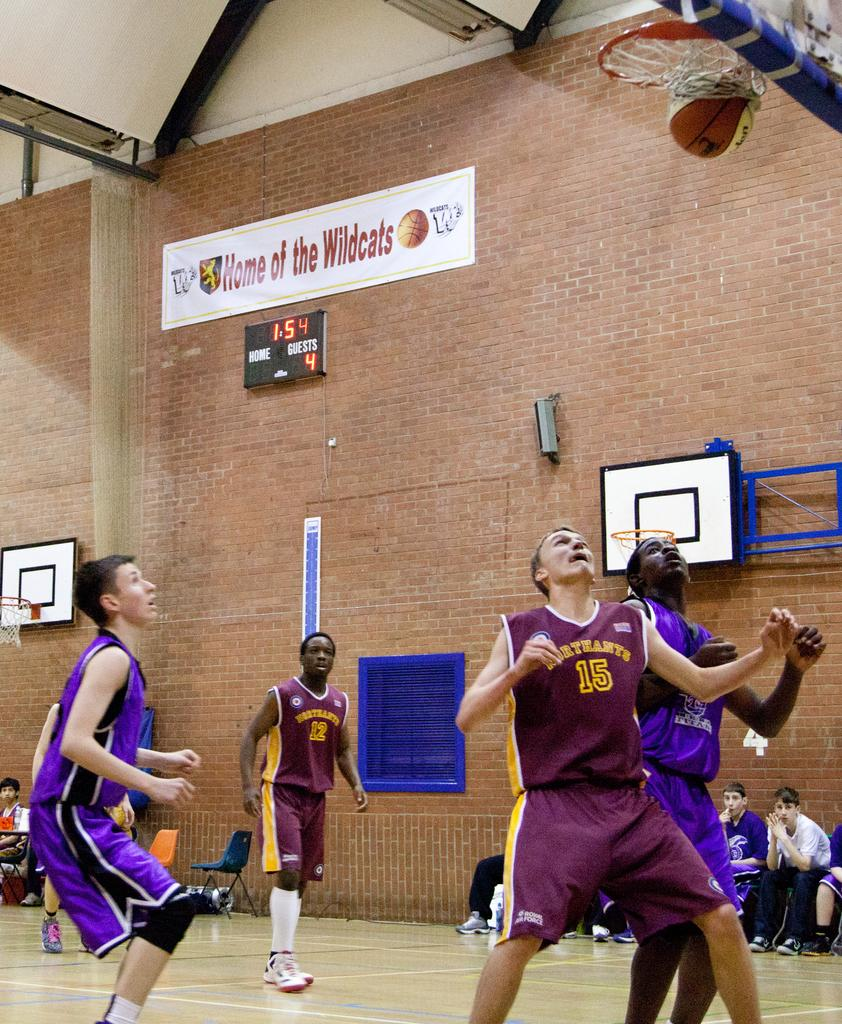<image>
Summarize the visual content of the image. The banner on the wall is for the Home of the Wildcats 